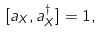<formula> <loc_0><loc_0><loc_500><loc_500>[ a _ { X } , a _ { X } ^ { \dagger } ] = 1 ,</formula> 